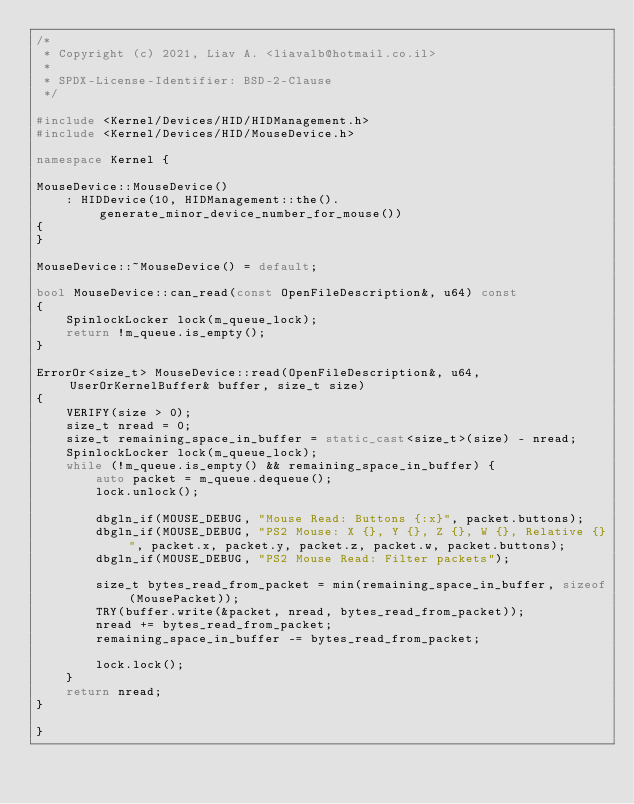Convert code to text. <code><loc_0><loc_0><loc_500><loc_500><_C++_>/*
 * Copyright (c) 2021, Liav A. <liavalb@hotmail.co.il>
 *
 * SPDX-License-Identifier: BSD-2-Clause
 */

#include <Kernel/Devices/HID/HIDManagement.h>
#include <Kernel/Devices/HID/MouseDevice.h>

namespace Kernel {

MouseDevice::MouseDevice()
    : HIDDevice(10, HIDManagement::the().generate_minor_device_number_for_mouse())
{
}

MouseDevice::~MouseDevice() = default;

bool MouseDevice::can_read(const OpenFileDescription&, u64) const
{
    SpinlockLocker lock(m_queue_lock);
    return !m_queue.is_empty();
}

ErrorOr<size_t> MouseDevice::read(OpenFileDescription&, u64, UserOrKernelBuffer& buffer, size_t size)
{
    VERIFY(size > 0);
    size_t nread = 0;
    size_t remaining_space_in_buffer = static_cast<size_t>(size) - nread;
    SpinlockLocker lock(m_queue_lock);
    while (!m_queue.is_empty() && remaining_space_in_buffer) {
        auto packet = m_queue.dequeue();
        lock.unlock();

        dbgln_if(MOUSE_DEBUG, "Mouse Read: Buttons {:x}", packet.buttons);
        dbgln_if(MOUSE_DEBUG, "PS2 Mouse: X {}, Y {}, Z {}, W {}, Relative {}", packet.x, packet.y, packet.z, packet.w, packet.buttons);
        dbgln_if(MOUSE_DEBUG, "PS2 Mouse Read: Filter packets");

        size_t bytes_read_from_packet = min(remaining_space_in_buffer, sizeof(MousePacket));
        TRY(buffer.write(&packet, nread, bytes_read_from_packet));
        nread += bytes_read_from_packet;
        remaining_space_in_buffer -= bytes_read_from_packet;

        lock.lock();
    }
    return nread;
}

}
</code> 